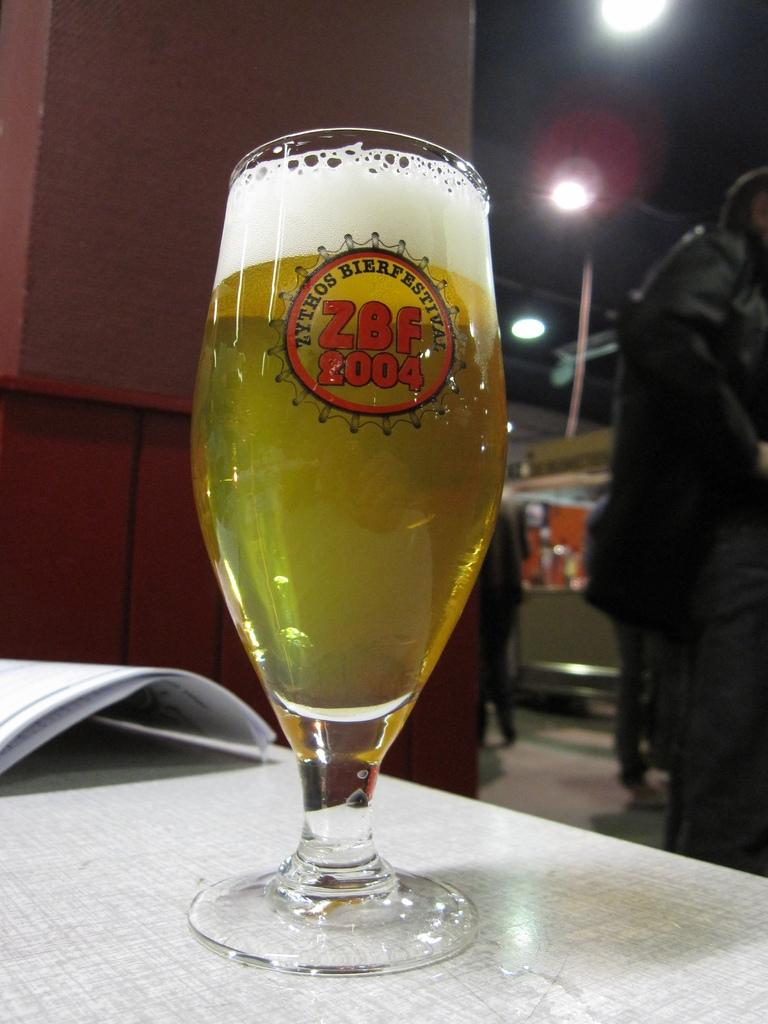What is in the glass that is visible in the image? There is a glass of beer in the image. What else can be seen on the table in the image? There is a paper on the table in the image. Can you describe the person in the image? There is a person standing on the backside of the image. What type of grape can be seen floating in the ocean in the image? There is no grape or ocean present in the image; it features a glass of beer, a paper on the table, and a person standing on the backside. 